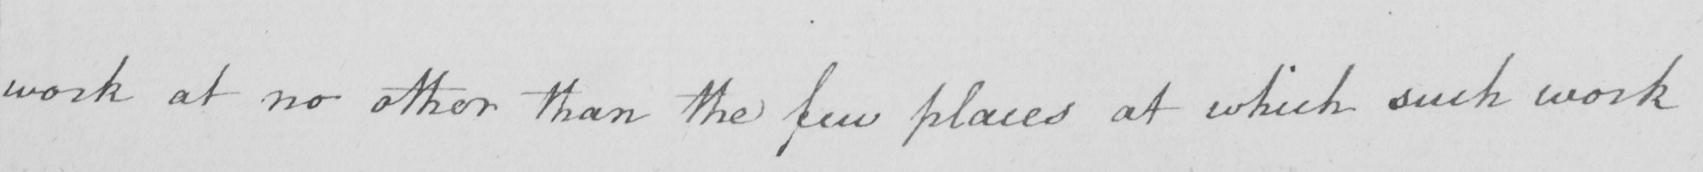What text is written in this handwritten line? work at no other than the few places at which such work 